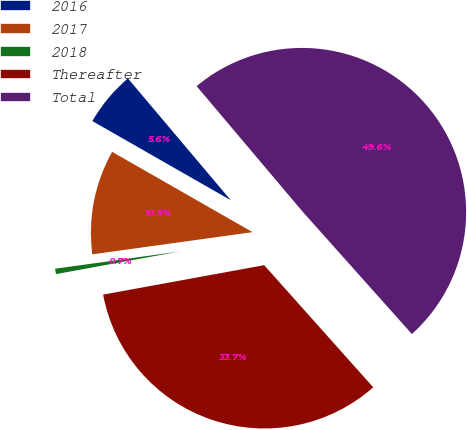Convert chart. <chart><loc_0><loc_0><loc_500><loc_500><pie_chart><fcel>2016<fcel>2017<fcel>2018<fcel>Thereafter<fcel>Total<nl><fcel>5.57%<fcel>10.46%<fcel>0.69%<fcel>33.72%<fcel>49.56%<nl></chart> 